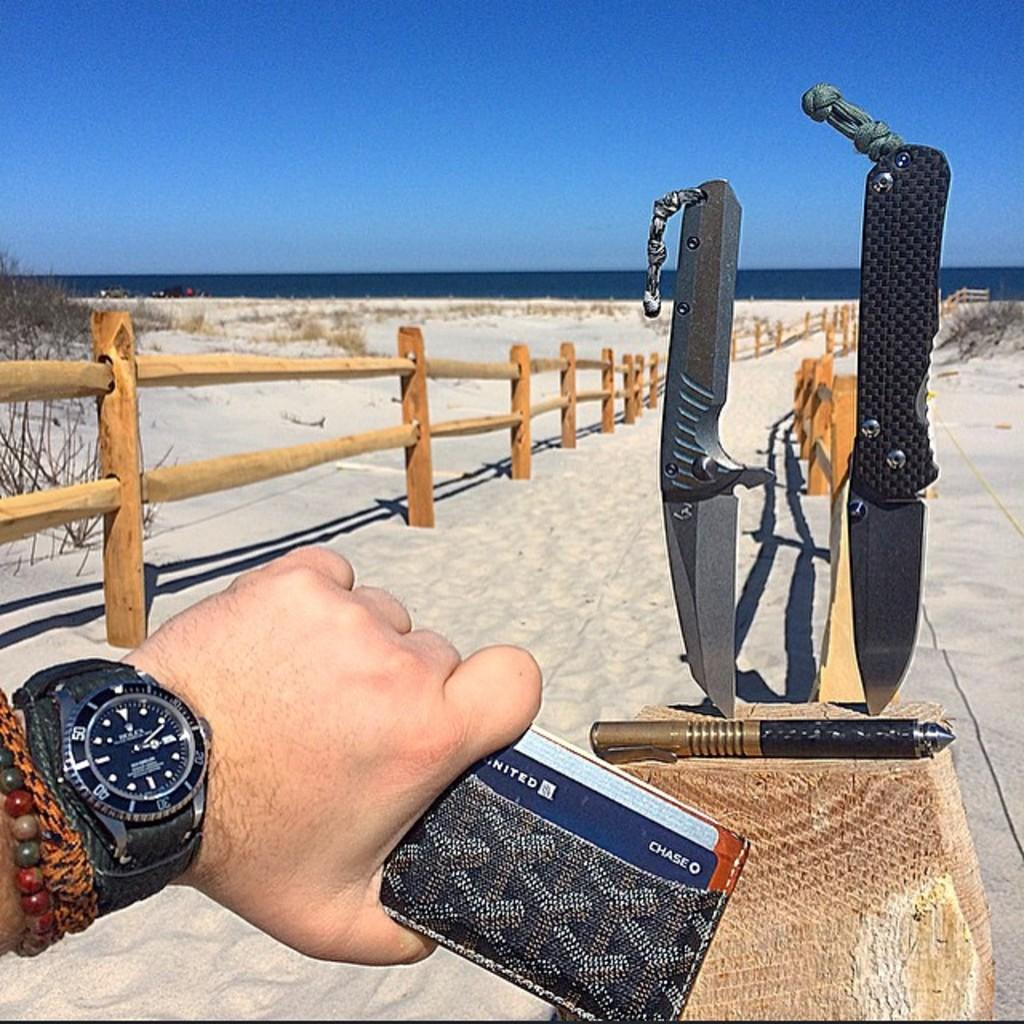<image>
Relay a brief, clear account of the picture shown. Two knives are displayed at a sandy beach, with a person holding a wallet with a United Chase card in the foreground. 